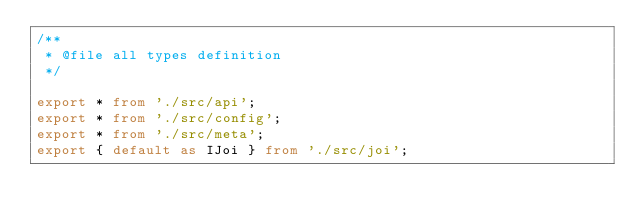Convert code to text. <code><loc_0><loc_0><loc_500><loc_500><_TypeScript_>/**
 * @file all types definition
 */

export * from './src/api';
export * from './src/config';
export * from './src/meta';
export { default as IJoi } from './src/joi';
</code> 